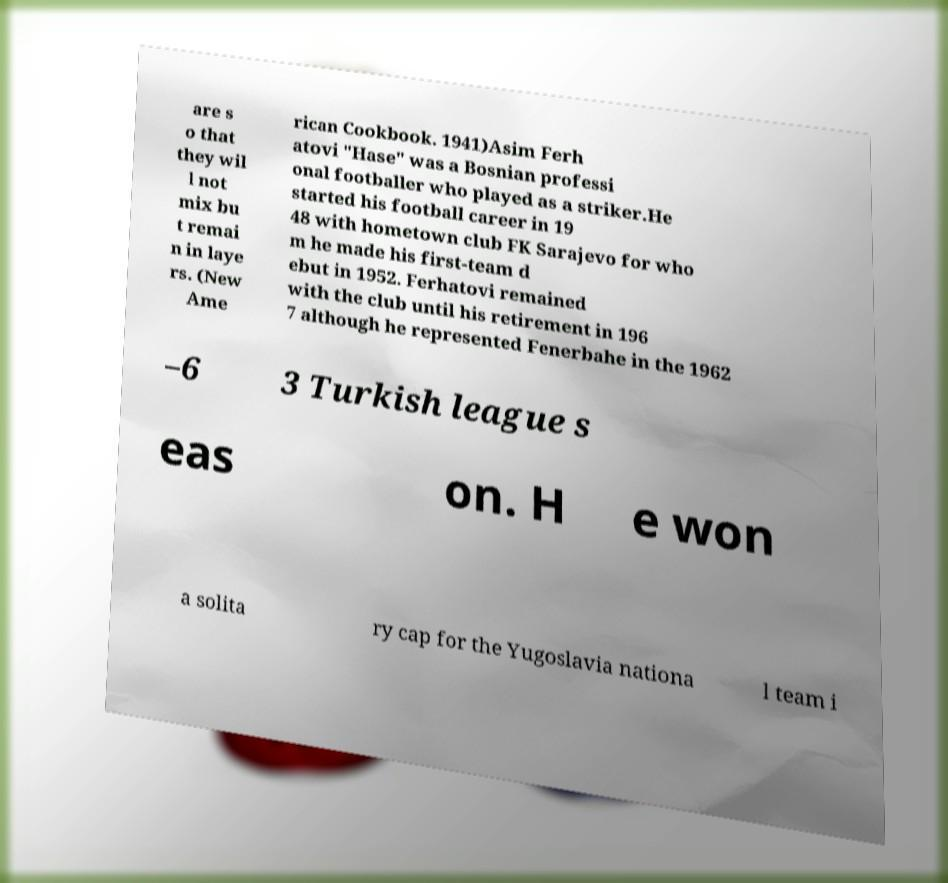Can you read and provide the text displayed in the image?This photo seems to have some interesting text. Can you extract and type it out for me? are s o that they wil l not mix bu t remai n in laye rs. (New Ame rican Cookbook. 1941)Asim Ferh atovi "Hase" was a Bosnian professi onal footballer who played as a striker.He started his football career in 19 48 with hometown club FK Sarajevo for who m he made his first-team d ebut in 1952. Ferhatovi remained with the club until his retirement in 196 7 although he represented Fenerbahe in the 1962 –6 3 Turkish league s eas on. H e won a solita ry cap for the Yugoslavia nationa l team i 